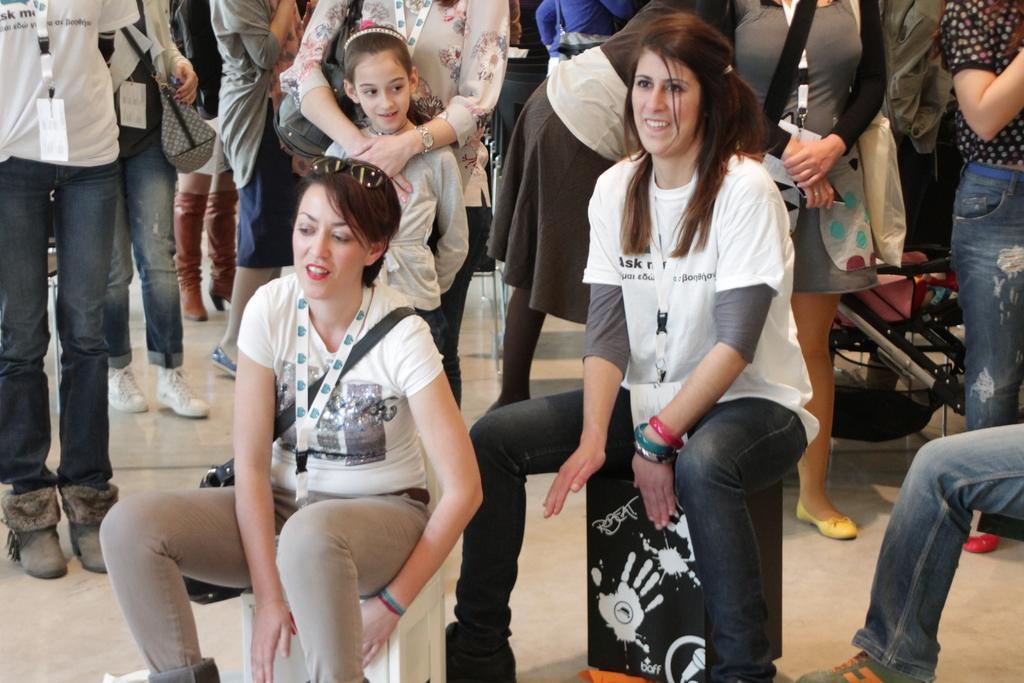How would you summarize this image in a sentence or two? In this picture we can observe two women sitting on the stools. Both of them are wearing white color T shirts and tags in their necks. In the background there is a girl standing. We can observe some people standing in the background. 